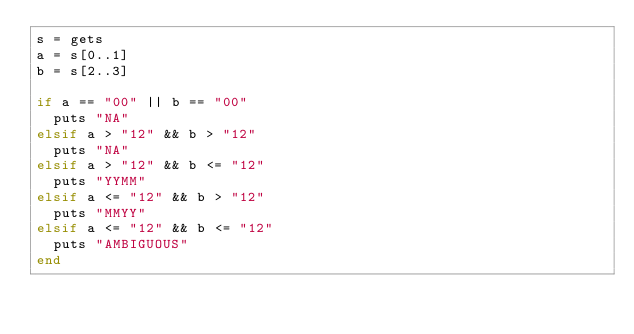<code> <loc_0><loc_0><loc_500><loc_500><_Ruby_>s = gets
a = s[0..1]
b = s[2..3]

if a == "00" || b == "00"
  puts "NA"
elsif a > "12" && b > "12"
  puts "NA"
elsif a > "12" && b <= "12"
  puts "YYMM"
elsif a <= "12" && b > "12"
  puts "MMYY"
elsif a <= "12" && b <= "12"
  puts "AMBIGUOUS"
end
</code> 